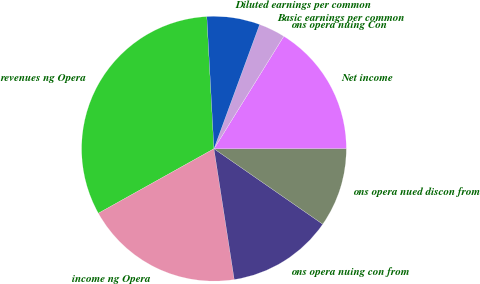Convert chart to OTSL. <chart><loc_0><loc_0><loc_500><loc_500><pie_chart><fcel>revenues ng Opera<fcel>income ng Opera<fcel>ons opera nuing con from<fcel>ons opera nued discon from<fcel>Net income<fcel>ons opera nuing Con<fcel>Basic earnings per common<fcel>Diluted earnings per common<nl><fcel>32.25%<fcel>19.35%<fcel>12.9%<fcel>9.68%<fcel>16.13%<fcel>0.01%<fcel>3.23%<fcel>6.46%<nl></chart> 